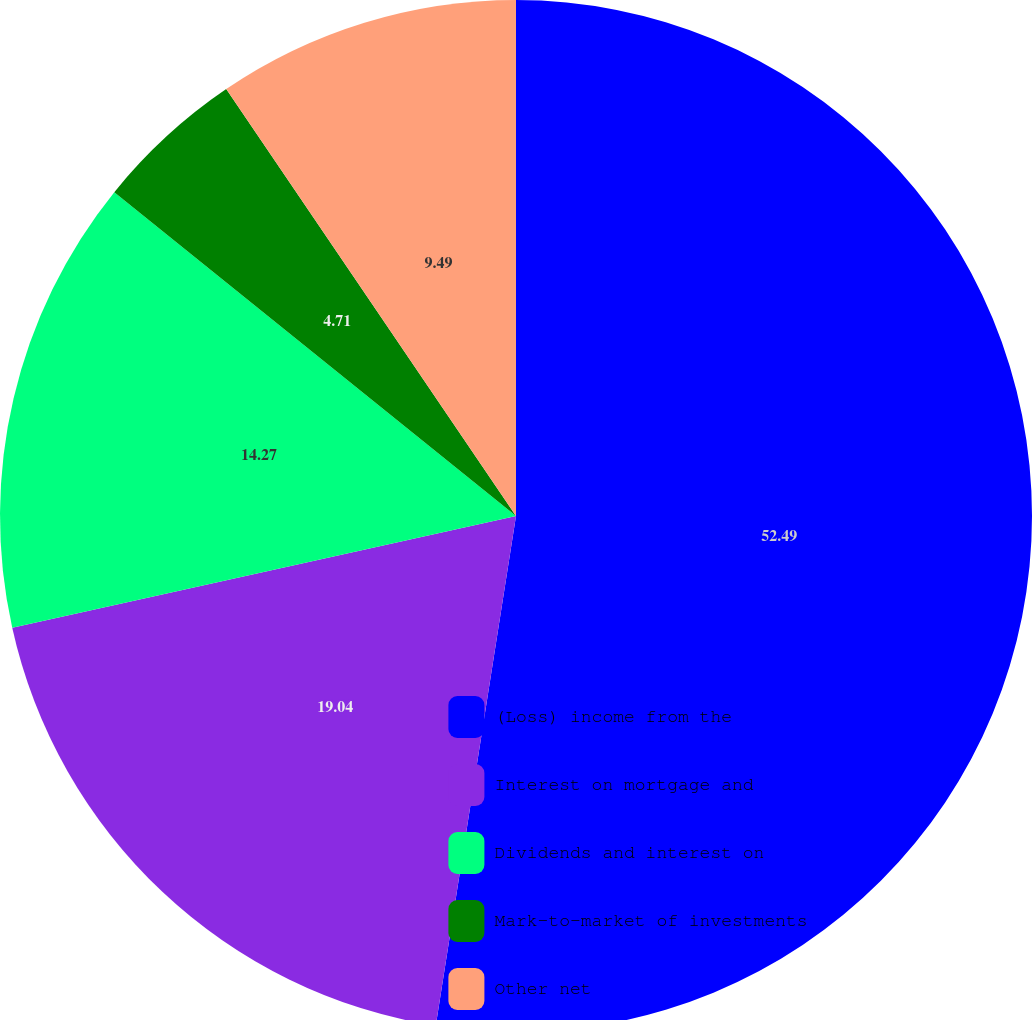<chart> <loc_0><loc_0><loc_500><loc_500><pie_chart><fcel>(Loss) income from the<fcel>Interest on mortgage and<fcel>Dividends and interest on<fcel>Mark-to-market of investments<fcel>Other net<nl><fcel>52.48%<fcel>19.04%<fcel>14.27%<fcel>4.71%<fcel>9.49%<nl></chart> 